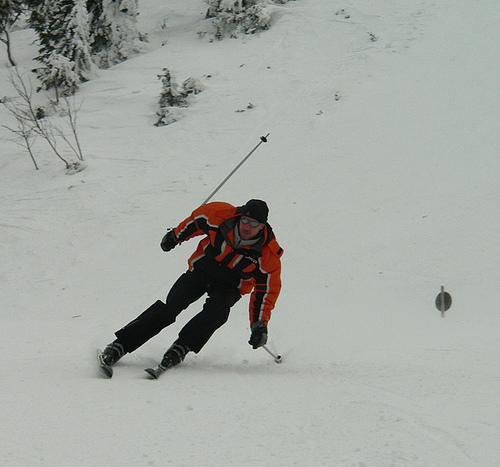How many skiers are there?
Give a very brief answer. 1. 